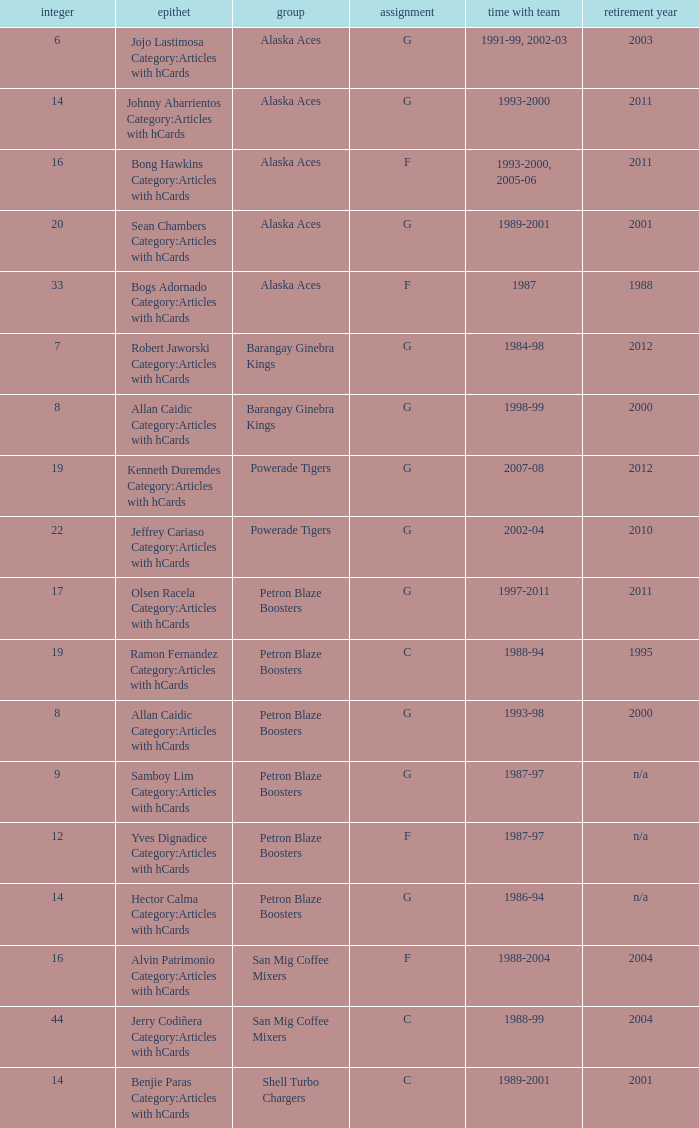How many years did the team in slot number 9 have a franchise? 1987-97. 